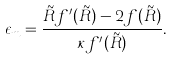<formula> <loc_0><loc_0><loc_500><loc_500>\epsilon _ { m } = \frac { \tilde { R } f ^ { \prime } ( \tilde { R } ) - 2 f ( \tilde { R } ) } { \kappa f ^ { \prime } ( \tilde { R } ) } .</formula> 